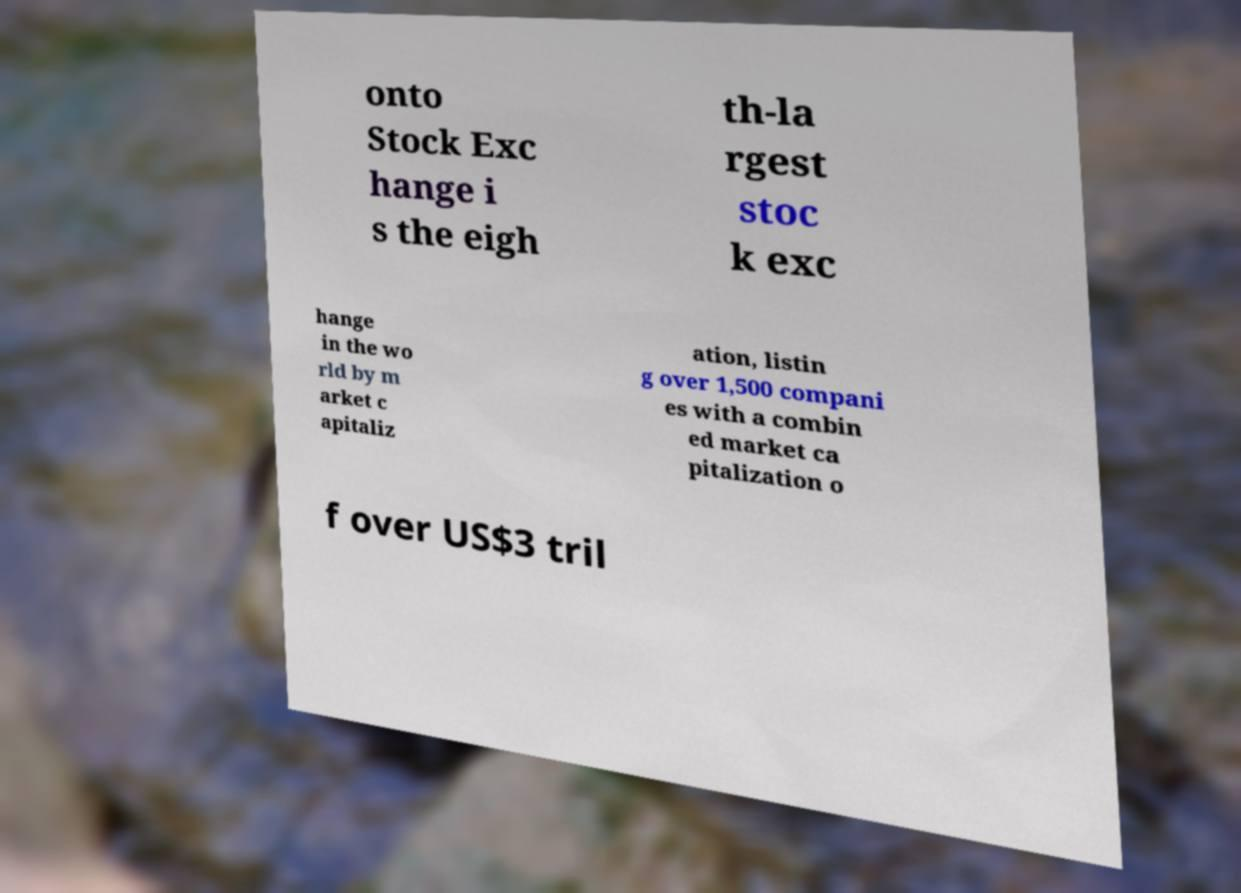Could you assist in decoding the text presented in this image and type it out clearly? onto Stock Exc hange i s the eigh th-la rgest stoc k exc hange in the wo rld by m arket c apitaliz ation, listin g over 1,500 compani es with a combin ed market ca pitalization o f over US$3 tril 